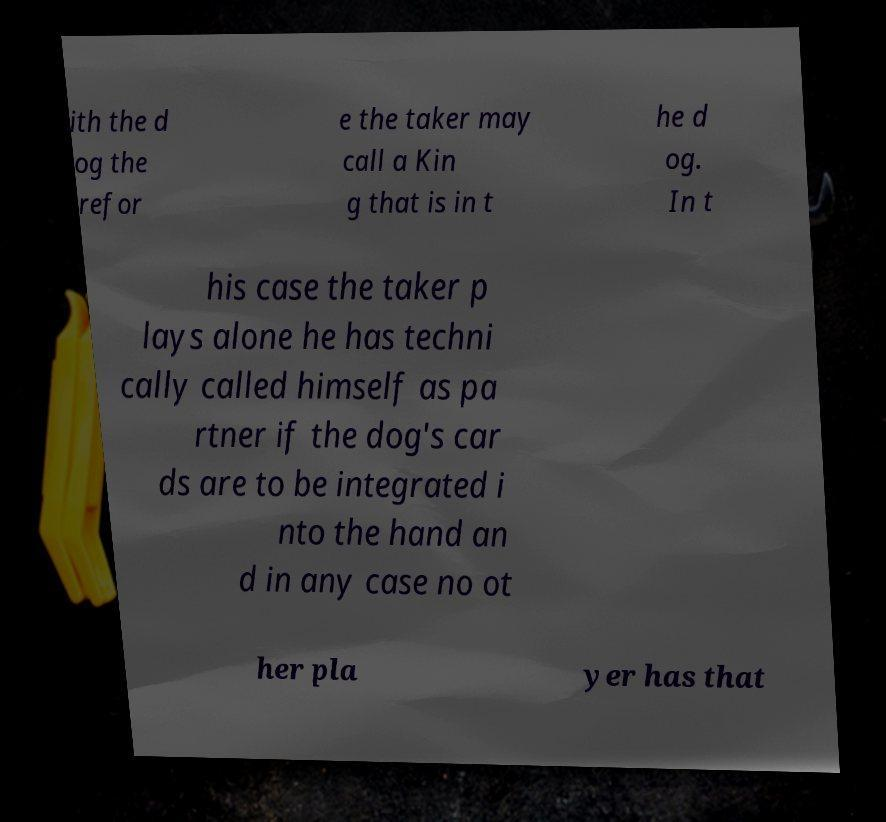What messages or text are displayed in this image? I need them in a readable, typed format. ith the d og the refor e the taker may call a Kin g that is in t he d og. In t his case the taker p lays alone he has techni cally called himself as pa rtner if the dog's car ds are to be integrated i nto the hand an d in any case no ot her pla yer has that 